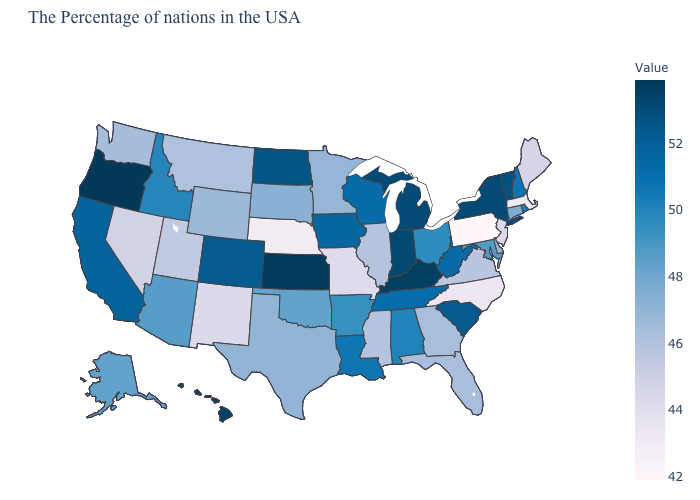Does California have a lower value than Kentucky?
Keep it brief. Yes. Among the states that border Colorado , which have the lowest value?
Write a very short answer. Nebraska. Among the states that border Delaware , does Maryland have the highest value?
Give a very brief answer. Yes. Which states have the lowest value in the South?
Quick response, please. North Carolina. 